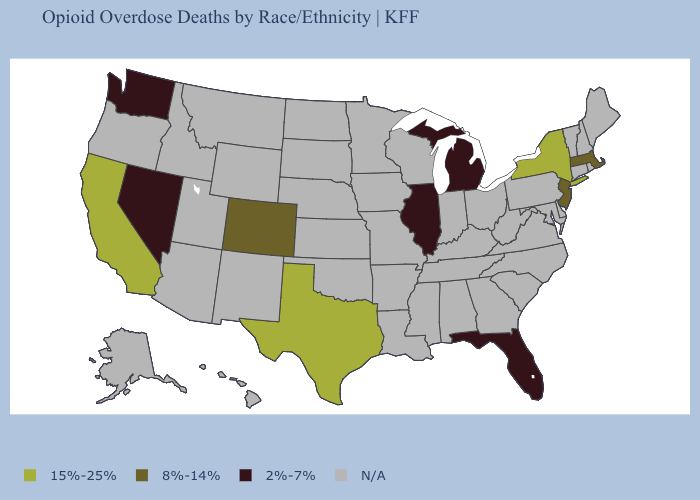What is the value of Iowa?
Be succinct. N/A. What is the lowest value in states that border Utah?
Short answer required. 2%-7%. What is the highest value in the West ?
Answer briefly. 15%-25%. What is the value of Massachusetts?
Write a very short answer. 8%-14%. What is the value of Oklahoma?
Write a very short answer. N/A. Which states hav the highest value in the South?
Quick response, please. Texas. What is the highest value in the USA?
Concise answer only. 15%-25%. What is the lowest value in states that border Indiana?
Be succinct. 2%-7%. What is the lowest value in the MidWest?
Concise answer only. 2%-7%. Which states have the lowest value in the South?
Write a very short answer. Florida. Does Texas have the lowest value in the South?
Concise answer only. No. Which states have the lowest value in the South?
Answer briefly. Florida. What is the value of Vermont?
Short answer required. N/A. What is the value of Delaware?
Concise answer only. N/A. 